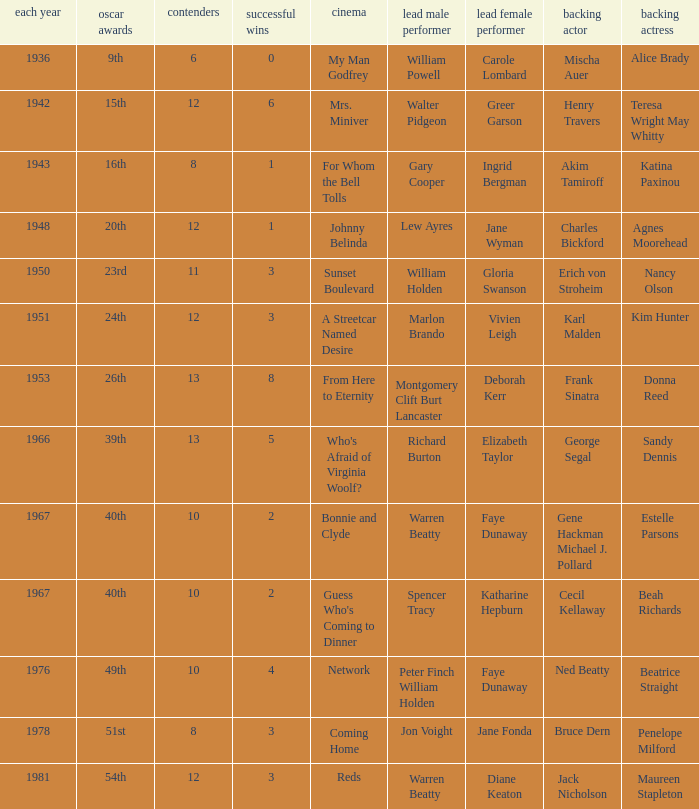Who was the supporting actress in "For Whom the Bell Tolls"? Katina Paxinou. 